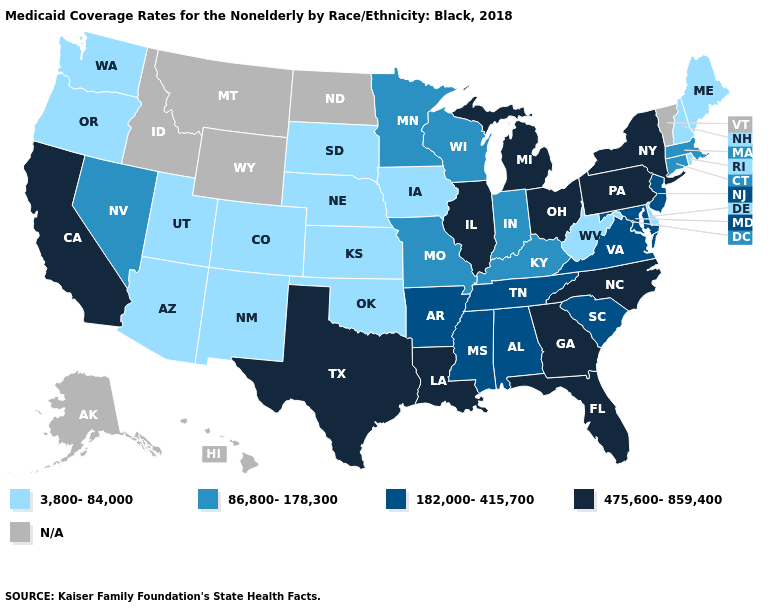Does Georgia have the lowest value in the South?
Give a very brief answer. No. Name the states that have a value in the range 475,600-859,400?
Keep it brief. California, Florida, Georgia, Illinois, Louisiana, Michigan, New York, North Carolina, Ohio, Pennsylvania, Texas. What is the lowest value in states that border Oregon?
Be succinct. 3,800-84,000. What is the value of North Carolina?
Concise answer only. 475,600-859,400. Name the states that have a value in the range 475,600-859,400?
Short answer required. California, Florida, Georgia, Illinois, Louisiana, Michigan, New York, North Carolina, Ohio, Pennsylvania, Texas. What is the value of Pennsylvania?
Concise answer only. 475,600-859,400. Does New York have the highest value in the Northeast?
Answer briefly. Yes. Among the states that border Virginia , which have the highest value?
Concise answer only. North Carolina. Does the map have missing data?
Concise answer only. Yes. Name the states that have a value in the range N/A?
Keep it brief. Alaska, Hawaii, Idaho, Montana, North Dakota, Vermont, Wyoming. What is the highest value in the USA?
Concise answer only. 475,600-859,400. What is the value of Kentucky?
Give a very brief answer. 86,800-178,300. Does the first symbol in the legend represent the smallest category?
Concise answer only. Yes. Does the first symbol in the legend represent the smallest category?
Give a very brief answer. Yes. What is the lowest value in states that border Kentucky?
Give a very brief answer. 3,800-84,000. 